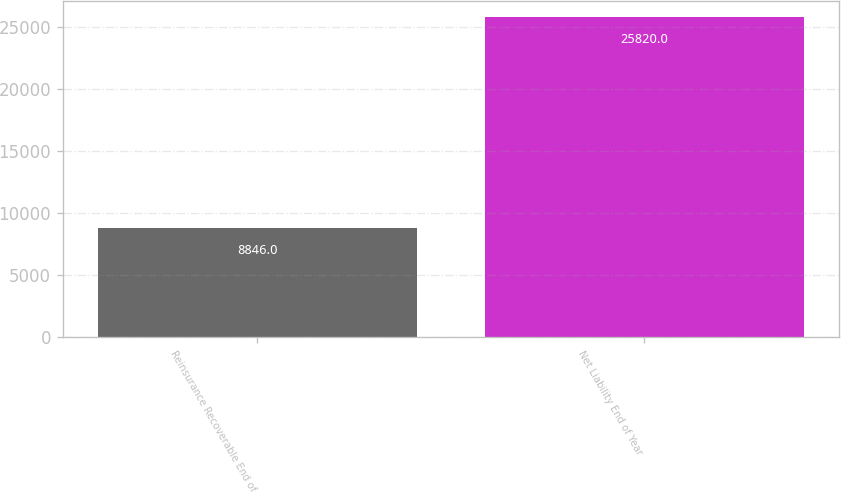Convert chart. <chart><loc_0><loc_0><loc_500><loc_500><bar_chart><fcel>Reinsurance Recoverable End of<fcel>Net Liability End of Year<nl><fcel>8846<fcel>25820<nl></chart> 